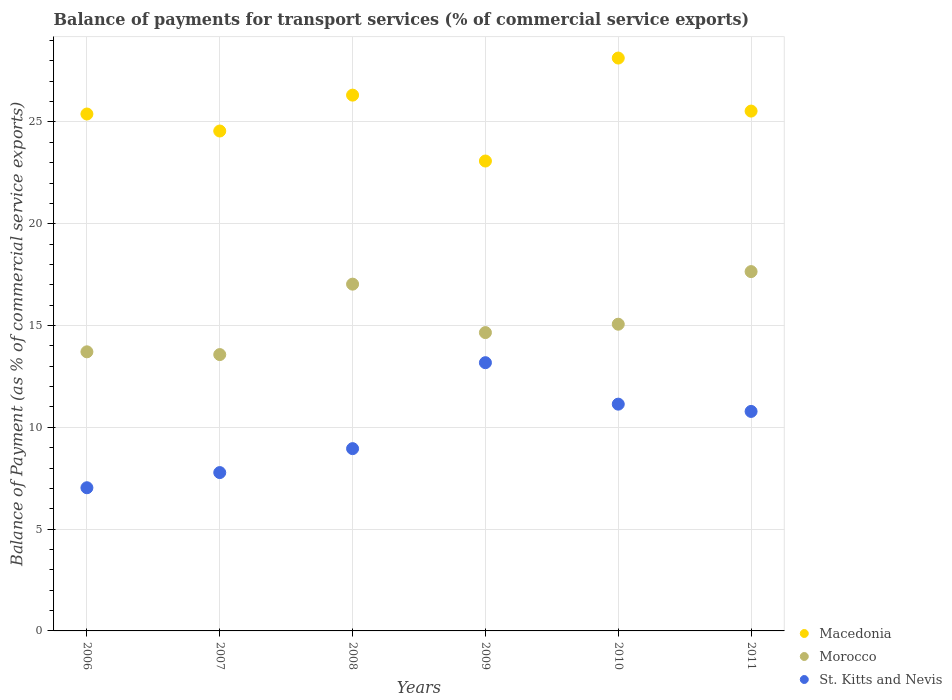How many different coloured dotlines are there?
Your answer should be very brief. 3. What is the balance of payments for transport services in Morocco in 2008?
Provide a short and direct response. 17.03. Across all years, what is the maximum balance of payments for transport services in Macedonia?
Your answer should be very brief. 28.14. Across all years, what is the minimum balance of payments for transport services in St. Kitts and Nevis?
Your response must be concise. 7.03. What is the total balance of payments for transport services in St. Kitts and Nevis in the graph?
Offer a terse response. 58.86. What is the difference between the balance of payments for transport services in Macedonia in 2006 and that in 2010?
Make the answer very short. -2.75. What is the difference between the balance of payments for transport services in St. Kitts and Nevis in 2006 and the balance of payments for transport services in Morocco in 2010?
Your answer should be very brief. -8.03. What is the average balance of payments for transport services in St. Kitts and Nevis per year?
Your answer should be compact. 9.81. In the year 2008, what is the difference between the balance of payments for transport services in Morocco and balance of payments for transport services in Macedonia?
Your response must be concise. -9.29. In how many years, is the balance of payments for transport services in Morocco greater than 22 %?
Offer a very short reply. 0. What is the ratio of the balance of payments for transport services in Morocco in 2009 to that in 2011?
Offer a terse response. 0.83. What is the difference between the highest and the second highest balance of payments for transport services in Morocco?
Your answer should be compact. 0.62. What is the difference between the highest and the lowest balance of payments for transport services in Macedonia?
Make the answer very short. 5.06. In how many years, is the balance of payments for transport services in Macedonia greater than the average balance of payments for transport services in Macedonia taken over all years?
Your answer should be compact. 3. Is the sum of the balance of payments for transport services in Macedonia in 2008 and 2010 greater than the maximum balance of payments for transport services in Morocco across all years?
Offer a terse response. Yes. Is the balance of payments for transport services in St. Kitts and Nevis strictly greater than the balance of payments for transport services in Macedonia over the years?
Your response must be concise. No. How many dotlines are there?
Provide a short and direct response. 3. How many years are there in the graph?
Provide a succinct answer. 6. Does the graph contain any zero values?
Your answer should be compact. No. How many legend labels are there?
Keep it short and to the point. 3. What is the title of the graph?
Provide a short and direct response. Balance of payments for transport services (% of commercial service exports). What is the label or title of the X-axis?
Provide a succinct answer. Years. What is the label or title of the Y-axis?
Your answer should be very brief. Balance of Payment (as % of commercial service exports). What is the Balance of Payment (as % of commercial service exports) in Macedonia in 2006?
Give a very brief answer. 25.39. What is the Balance of Payment (as % of commercial service exports) of Morocco in 2006?
Your answer should be very brief. 13.71. What is the Balance of Payment (as % of commercial service exports) of St. Kitts and Nevis in 2006?
Your answer should be very brief. 7.03. What is the Balance of Payment (as % of commercial service exports) of Macedonia in 2007?
Make the answer very short. 24.56. What is the Balance of Payment (as % of commercial service exports) of Morocco in 2007?
Ensure brevity in your answer.  13.57. What is the Balance of Payment (as % of commercial service exports) of St. Kitts and Nevis in 2007?
Provide a succinct answer. 7.78. What is the Balance of Payment (as % of commercial service exports) in Macedonia in 2008?
Keep it short and to the point. 26.32. What is the Balance of Payment (as % of commercial service exports) in Morocco in 2008?
Your answer should be very brief. 17.03. What is the Balance of Payment (as % of commercial service exports) in St. Kitts and Nevis in 2008?
Your answer should be compact. 8.95. What is the Balance of Payment (as % of commercial service exports) of Macedonia in 2009?
Your answer should be very brief. 23.08. What is the Balance of Payment (as % of commercial service exports) of Morocco in 2009?
Offer a terse response. 14.66. What is the Balance of Payment (as % of commercial service exports) of St. Kitts and Nevis in 2009?
Your answer should be compact. 13.18. What is the Balance of Payment (as % of commercial service exports) in Macedonia in 2010?
Your answer should be compact. 28.14. What is the Balance of Payment (as % of commercial service exports) in Morocco in 2010?
Your answer should be compact. 15.07. What is the Balance of Payment (as % of commercial service exports) in St. Kitts and Nevis in 2010?
Ensure brevity in your answer.  11.14. What is the Balance of Payment (as % of commercial service exports) in Macedonia in 2011?
Provide a short and direct response. 25.54. What is the Balance of Payment (as % of commercial service exports) in Morocco in 2011?
Ensure brevity in your answer.  17.65. What is the Balance of Payment (as % of commercial service exports) of St. Kitts and Nevis in 2011?
Make the answer very short. 10.78. Across all years, what is the maximum Balance of Payment (as % of commercial service exports) in Macedonia?
Offer a very short reply. 28.14. Across all years, what is the maximum Balance of Payment (as % of commercial service exports) of Morocco?
Your answer should be compact. 17.65. Across all years, what is the maximum Balance of Payment (as % of commercial service exports) of St. Kitts and Nevis?
Your response must be concise. 13.18. Across all years, what is the minimum Balance of Payment (as % of commercial service exports) of Macedonia?
Offer a terse response. 23.08. Across all years, what is the minimum Balance of Payment (as % of commercial service exports) in Morocco?
Make the answer very short. 13.57. Across all years, what is the minimum Balance of Payment (as % of commercial service exports) of St. Kitts and Nevis?
Your answer should be very brief. 7.03. What is the total Balance of Payment (as % of commercial service exports) of Macedonia in the graph?
Your answer should be very brief. 153.03. What is the total Balance of Payment (as % of commercial service exports) of Morocco in the graph?
Offer a very short reply. 91.69. What is the total Balance of Payment (as % of commercial service exports) in St. Kitts and Nevis in the graph?
Your answer should be compact. 58.86. What is the difference between the Balance of Payment (as % of commercial service exports) in Macedonia in 2006 and that in 2007?
Offer a terse response. 0.84. What is the difference between the Balance of Payment (as % of commercial service exports) in Morocco in 2006 and that in 2007?
Offer a terse response. 0.14. What is the difference between the Balance of Payment (as % of commercial service exports) of St. Kitts and Nevis in 2006 and that in 2007?
Your answer should be compact. -0.74. What is the difference between the Balance of Payment (as % of commercial service exports) of Macedonia in 2006 and that in 2008?
Provide a short and direct response. -0.93. What is the difference between the Balance of Payment (as % of commercial service exports) in Morocco in 2006 and that in 2008?
Provide a succinct answer. -3.32. What is the difference between the Balance of Payment (as % of commercial service exports) of St. Kitts and Nevis in 2006 and that in 2008?
Offer a very short reply. -1.92. What is the difference between the Balance of Payment (as % of commercial service exports) of Macedonia in 2006 and that in 2009?
Offer a terse response. 2.31. What is the difference between the Balance of Payment (as % of commercial service exports) in Morocco in 2006 and that in 2009?
Offer a very short reply. -0.94. What is the difference between the Balance of Payment (as % of commercial service exports) of St. Kitts and Nevis in 2006 and that in 2009?
Give a very brief answer. -6.14. What is the difference between the Balance of Payment (as % of commercial service exports) in Macedonia in 2006 and that in 2010?
Your response must be concise. -2.75. What is the difference between the Balance of Payment (as % of commercial service exports) of Morocco in 2006 and that in 2010?
Your answer should be very brief. -1.36. What is the difference between the Balance of Payment (as % of commercial service exports) in St. Kitts and Nevis in 2006 and that in 2010?
Your answer should be compact. -4.11. What is the difference between the Balance of Payment (as % of commercial service exports) in Macedonia in 2006 and that in 2011?
Your answer should be compact. -0.14. What is the difference between the Balance of Payment (as % of commercial service exports) in Morocco in 2006 and that in 2011?
Make the answer very short. -3.94. What is the difference between the Balance of Payment (as % of commercial service exports) in St. Kitts and Nevis in 2006 and that in 2011?
Provide a short and direct response. -3.75. What is the difference between the Balance of Payment (as % of commercial service exports) in Macedonia in 2007 and that in 2008?
Your answer should be compact. -1.76. What is the difference between the Balance of Payment (as % of commercial service exports) in Morocco in 2007 and that in 2008?
Ensure brevity in your answer.  -3.46. What is the difference between the Balance of Payment (as % of commercial service exports) of St. Kitts and Nevis in 2007 and that in 2008?
Keep it short and to the point. -1.18. What is the difference between the Balance of Payment (as % of commercial service exports) in Macedonia in 2007 and that in 2009?
Give a very brief answer. 1.47. What is the difference between the Balance of Payment (as % of commercial service exports) in Morocco in 2007 and that in 2009?
Offer a very short reply. -1.08. What is the difference between the Balance of Payment (as % of commercial service exports) in St. Kitts and Nevis in 2007 and that in 2009?
Give a very brief answer. -5.4. What is the difference between the Balance of Payment (as % of commercial service exports) of Macedonia in 2007 and that in 2010?
Provide a succinct answer. -3.58. What is the difference between the Balance of Payment (as % of commercial service exports) of Morocco in 2007 and that in 2010?
Offer a terse response. -1.49. What is the difference between the Balance of Payment (as % of commercial service exports) in St. Kitts and Nevis in 2007 and that in 2010?
Give a very brief answer. -3.36. What is the difference between the Balance of Payment (as % of commercial service exports) of Macedonia in 2007 and that in 2011?
Ensure brevity in your answer.  -0.98. What is the difference between the Balance of Payment (as % of commercial service exports) of Morocco in 2007 and that in 2011?
Give a very brief answer. -4.08. What is the difference between the Balance of Payment (as % of commercial service exports) of St. Kitts and Nevis in 2007 and that in 2011?
Your answer should be compact. -3. What is the difference between the Balance of Payment (as % of commercial service exports) in Macedonia in 2008 and that in 2009?
Keep it short and to the point. 3.24. What is the difference between the Balance of Payment (as % of commercial service exports) in Morocco in 2008 and that in 2009?
Ensure brevity in your answer.  2.38. What is the difference between the Balance of Payment (as % of commercial service exports) of St. Kitts and Nevis in 2008 and that in 2009?
Make the answer very short. -4.22. What is the difference between the Balance of Payment (as % of commercial service exports) of Macedonia in 2008 and that in 2010?
Your answer should be compact. -1.82. What is the difference between the Balance of Payment (as % of commercial service exports) in Morocco in 2008 and that in 2010?
Provide a succinct answer. 1.97. What is the difference between the Balance of Payment (as % of commercial service exports) in St. Kitts and Nevis in 2008 and that in 2010?
Your answer should be very brief. -2.19. What is the difference between the Balance of Payment (as % of commercial service exports) in Macedonia in 2008 and that in 2011?
Make the answer very short. 0.78. What is the difference between the Balance of Payment (as % of commercial service exports) in Morocco in 2008 and that in 2011?
Make the answer very short. -0.62. What is the difference between the Balance of Payment (as % of commercial service exports) of St. Kitts and Nevis in 2008 and that in 2011?
Make the answer very short. -1.83. What is the difference between the Balance of Payment (as % of commercial service exports) of Macedonia in 2009 and that in 2010?
Make the answer very short. -5.06. What is the difference between the Balance of Payment (as % of commercial service exports) of Morocco in 2009 and that in 2010?
Give a very brief answer. -0.41. What is the difference between the Balance of Payment (as % of commercial service exports) of St. Kitts and Nevis in 2009 and that in 2010?
Your answer should be very brief. 2.04. What is the difference between the Balance of Payment (as % of commercial service exports) in Macedonia in 2009 and that in 2011?
Provide a short and direct response. -2.45. What is the difference between the Balance of Payment (as % of commercial service exports) in Morocco in 2009 and that in 2011?
Keep it short and to the point. -3. What is the difference between the Balance of Payment (as % of commercial service exports) of St. Kitts and Nevis in 2009 and that in 2011?
Make the answer very short. 2.39. What is the difference between the Balance of Payment (as % of commercial service exports) in Macedonia in 2010 and that in 2011?
Ensure brevity in your answer.  2.6. What is the difference between the Balance of Payment (as % of commercial service exports) in Morocco in 2010 and that in 2011?
Your response must be concise. -2.58. What is the difference between the Balance of Payment (as % of commercial service exports) of St. Kitts and Nevis in 2010 and that in 2011?
Provide a succinct answer. 0.36. What is the difference between the Balance of Payment (as % of commercial service exports) in Macedonia in 2006 and the Balance of Payment (as % of commercial service exports) in Morocco in 2007?
Provide a succinct answer. 11.82. What is the difference between the Balance of Payment (as % of commercial service exports) in Macedonia in 2006 and the Balance of Payment (as % of commercial service exports) in St. Kitts and Nevis in 2007?
Your answer should be compact. 17.61. What is the difference between the Balance of Payment (as % of commercial service exports) in Morocco in 2006 and the Balance of Payment (as % of commercial service exports) in St. Kitts and Nevis in 2007?
Give a very brief answer. 5.93. What is the difference between the Balance of Payment (as % of commercial service exports) in Macedonia in 2006 and the Balance of Payment (as % of commercial service exports) in Morocco in 2008?
Provide a short and direct response. 8.36. What is the difference between the Balance of Payment (as % of commercial service exports) in Macedonia in 2006 and the Balance of Payment (as % of commercial service exports) in St. Kitts and Nevis in 2008?
Keep it short and to the point. 16.44. What is the difference between the Balance of Payment (as % of commercial service exports) of Morocco in 2006 and the Balance of Payment (as % of commercial service exports) of St. Kitts and Nevis in 2008?
Your answer should be very brief. 4.76. What is the difference between the Balance of Payment (as % of commercial service exports) of Macedonia in 2006 and the Balance of Payment (as % of commercial service exports) of Morocco in 2009?
Provide a short and direct response. 10.74. What is the difference between the Balance of Payment (as % of commercial service exports) of Macedonia in 2006 and the Balance of Payment (as % of commercial service exports) of St. Kitts and Nevis in 2009?
Provide a succinct answer. 12.22. What is the difference between the Balance of Payment (as % of commercial service exports) of Morocco in 2006 and the Balance of Payment (as % of commercial service exports) of St. Kitts and Nevis in 2009?
Provide a succinct answer. 0.53. What is the difference between the Balance of Payment (as % of commercial service exports) in Macedonia in 2006 and the Balance of Payment (as % of commercial service exports) in Morocco in 2010?
Provide a short and direct response. 10.33. What is the difference between the Balance of Payment (as % of commercial service exports) in Macedonia in 2006 and the Balance of Payment (as % of commercial service exports) in St. Kitts and Nevis in 2010?
Provide a succinct answer. 14.25. What is the difference between the Balance of Payment (as % of commercial service exports) of Morocco in 2006 and the Balance of Payment (as % of commercial service exports) of St. Kitts and Nevis in 2010?
Provide a succinct answer. 2.57. What is the difference between the Balance of Payment (as % of commercial service exports) in Macedonia in 2006 and the Balance of Payment (as % of commercial service exports) in Morocco in 2011?
Provide a short and direct response. 7.74. What is the difference between the Balance of Payment (as % of commercial service exports) of Macedonia in 2006 and the Balance of Payment (as % of commercial service exports) of St. Kitts and Nevis in 2011?
Make the answer very short. 14.61. What is the difference between the Balance of Payment (as % of commercial service exports) in Morocco in 2006 and the Balance of Payment (as % of commercial service exports) in St. Kitts and Nevis in 2011?
Offer a very short reply. 2.93. What is the difference between the Balance of Payment (as % of commercial service exports) in Macedonia in 2007 and the Balance of Payment (as % of commercial service exports) in Morocco in 2008?
Your response must be concise. 7.52. What is the difference between the Balance of Payment (as % of commercial service exports) in Macedonia in 2007 and the Balance of Payment (as % of commercial service exports) in St. Kitts and Nevis in 2008?
Make the answer very short. 15.6. What is the difference between the Balance of Payment (as % of commercial service exports) of Morocco in 2007 and the Balance of Payment (as % of commercial service exports) of St. Kitts and Nevis in 2008?
Ensure brevity in your answer.  4.62. What is the difference between the Balance of Payment (as % of commercial service exports) of Macedonia in 2007 and the Balance of Payment (as % of commercial service exports) of Morocco in 2009?
Keep it short and to the point. 9.9. What is the difference between the Balance of Payment (as % of commercial service exports) of Macedonia in 2007 and the Balance of Payment (as % of commercial service exports) of St. Kitts and Nevis in 2009?
Ensure brevity in your answer.  11.38. What is the difference between the Balance of Payment (as % of commercial service exports) in Morocco in 2007 and the Balance of Payment (as % of commercial service exports) in St. Kitts and Nevis in 2009?
Provide a succinct answer. 0.4. What is the difference between the Balance of Payment (as % of commercial service exports) in Macedonia in 2007 and the Balance of Payment (as % of commercial service exports) in Morocco in 2010?
Give a very brief answer. 9.49. What is the difference between the Balance of Payment (as % of commercial service exports) of Macedonia in 2007 and the Balance of Payment (as % of commercial service exports) of St. Kitts and Nevis in 2010?
Offer a terse response. 13.42. What is the difference between the Balance of Payment (as % of commercial service exports) in Morocco in 2007 and the Balance of Payment (as % of commercial service exports) in St. Kitts and Nevis in 2010?
Your response must be concise. 2.44. What is the difference between the Balance of Payment (as % of commercial service exports) in Macedonia in 2007 and the Balance of Payment (as % of commercial service exports) in Morocco in 2011?
Give a very brief answer. 6.91. What is the difference between the Balance of Payment (as % of commercial service exports) in Macedonia in 2007 and the Balance of Payment (as % of commercial service exports) in St. Kitts and Nevis in 2011?
Offer a terse response. 13.77. What is the difference between the Balance of Payment (as % of commercial service exports) in Morocco in 2007 and the Balance of Payment (as % of commercial service exports) in St. Kitts and Nevis in 2011?
Provide a succinct answer. 2.79. What is the difference between the Balance of Payment (as % of commercial service exports) of Macedonia in 2008 and the Balance of Payment (as % of commercial service exports) of Morocco in 2009?
Ensure brevity in your answer.  11.66. What is the difference between the Balance of Payment (as % of commercial service exports) of Macedonia in 2008 and the Balance of Payment (as % of commercial service exports) of St. Kitts and Nevis in 2009?
Offer a terse response. 13.14. What is the difference between the Balance of Payment (as % of commercial service exports) in Morocco in 2008 and the Balance of Payment (as % of commercial service exports) in St. Kitts and Nevis in 2009?
Offer a very short reply. 3.86. What is the difference between the Balance of Payment (as % of commercial service exports) in Macedonia in 2008 and the Balance of Payment (as % of commercial service exports) in Morocco in 2010?
Give a very brief answer. 11.25. What is the difference between the Balance of Payment (as % of commercial service exports) in Macedonia in 2008 and the Balance of Payment (as % of commercial service exports) in St. Kitts and Nevis in 2010?
Your answer should be compact. 15.18. What is the difference between the Balance of Payment (as % of commercial service exports) of Morocco in 2008 and the Balance of Payment (as % of commercial service exports) of St. Kitts and Nevis in 2010?
Your answer should be compact. 5.89. What is the difference between the Balance of Payment (as % of commercial service exports) of Macedonia in 2008 and the Balance of Payment (as % of commercial service exports) of Morocco in 2011?
Your answer should be very brief. 8.67. What is the difference between the Balance of Payment (as % of commercial service exports) in Macedonia in 2008 and the Balance of Payment (as % of commercial service exports) in St. Kitts and Nevis in 2011?
Provide a short and direct response. 15.54. What is the difference between the Balance of Payment (as % of commercial service exports) in Morocco in 2008 and the Balance of Payment (as % of commercial service exports) in St. Kitts and Nevis in 2011?
Your response must be concise. 6.25. What is the difference between the Balance of Payment (as % of commercial service exports) of Macedonia in 2009 and the Balance of Payment (as % of commercial service exports) of Morocco in 2010?
Give a very brief answer. 8.02. What is the difference between the Balance of Payment (as % of commercial service exports) of Macedonia in 2009 and the Balance of Payment (as % of commercial service exports) of St. Kitts and Nevis in 2010?
Your response must be concise. 11.94. What is the difference between the Balance of Payment (as % of commercial service exports) of Morocco in 2009 and the Balance of Payment (as % of commercial service exports) of St. Kitts and Nevis in 2010?
Offer a terse response. 3.52. What is the difference between the Balance of Payment (as % of commercial service exports) of Macedonia in 2009 and the Balance of Payment (as % of commercial service exports) of Morocco in 2011?
Keep it short and to the point. 5.43. What is the difference between the Balance of Payment (as % of commercial service exports) of Macedonia in 2009 and the Balance of Payment (as % of commercial service exports) of St. Kitts and Nevis in 2011?
Offer a terse response. 12.3. What is the difference between the Balance of Payment (as % of commercial service exports) in Morocco in 2009 and the Balance of Payment (as % of commercial service exports) in St. Kitts and Nevis in 2011?
Keep it short and to the point. 3.87. What is the difference between the Balance of Payment (as % of commercial service exports) of Macedonia in 2010 and the Balance of Payment (as % of commercial service exports) of Morocco in 2011?
Keep it short and to the point. 10.49. What is the difference between the Balance of Payment (as % of commercial service exports) in Macedonia in 2010 and the Balance of Payment (as % of commercial service exports) in St. Kitts and Nevis in 2011?
Provide a succinct answer. 17.36. What is the difference between the Balance of Payment (as % of commercial service exports) of Morocco in 2010 and the Balance of Payment (as % of commercial service exports) of St. Kitts and Nevis in 2011?
Your response must be concise. 4.28. What is the average Balance of Payment (as % of commercial service exports) in Macedonia per year?
Offer a very short reply. 25.5. What is the average Balance of Payment (as % of commercial service exports) in Morocco per year?
Your answer should be very brief. 15.28. What is the average Balance of Payment (as % of commercial service exports) in St. Kitts and Nevis per year?
Make the answer very short. 9.81. In the year 2006, what is the difference between the Balance of Payment (as % of commercial service exports) of Macedonia and Balance of Payment (as % of commercial service exports) of Morocco?
Keep it short and to the point. 11.68. In the year 2006, what is the difference between the Balance of Payment (as % of commercial service exports) of Macedonia and Balance of Payment (as % of commercial service exports) of St. Kitts and Nevis?
Provide a short and direct response. 18.36. In the year 2006, what is the difference between the Balance of Payment (as % of commercial service exports) in Morocco and Balance of Payment (as % of commercial service exports) in St. Kitts and Nevis?
Your response must be concise. 6.68. In the year 2007, what is the difference between the Balance of Payment (as % of commercial service exports) of Macedonia and Balance of Payment (as % of commercial service exports) of Morocco?
Offer a very short reply. 10.98. In the year 2007, what is the difference between the Balance of Payment (as % of commercial service exports) of Macedonia and Balance of Payment (as % of commercial service exports) of St. Kitts and Nevis?
Give a very brief answer. 16.78. In the year 2007, what is the difference between the Balance of Payment (as % of commercial service exports) of Morocco and Balance of Payment (as % of commercial service exports) of St. Kitts and Nevis?
Ensure brevity in your answer.  5.8. In the year 2008, what is the difference between the Balance of Payment (as % of commercial service exports) in Macedonia and Balance of Payment (as % of commercial service exports) in Morocco?
Provide a succinct answer. 9.29. In the year 2008, what is the difference between the Balance of Payment (as % of commercial service exports) in Macedonia and Balance of Payment (as % of commercial service exports) in St. Kitts and Nevis?
Your answer should be very brief. 17.37. In the year 2008, what is the difference between the Balance of Payment (as % of commercial service exports) in Morocco and Balance of Payment (as % of commercial service exports) in St. Kitts and Nevis?
Offer a very short reply. 8.08. In the year 2009, what is the difference between the Balance of Payment (as % of commercial service exports) of Macedonia and Balance of Payment (as % of commercial service exports) of Morocco?
Your response must be concise. 8.43. In the year 2009, what is the difference between the Balance of Payment (as % of commercial service exports) in Macedonia and Balance of Payment (as % of commercial service exports) in St. Kitts and Nevis?
Ensure brevity in your answer.  9.91. In the year 2009, what is the difference between the Balance of Payment (as % of commercial service exports) in Morocco and Balance of Payment (as % of commercial service exports) in St. Kitts and Nevis?
Keep it short and to the point. 1.48. In the year 2010, what is the difference between the Balance of Payment (as % of commercial service exports) of Macedonia and Balance of Payment (as % of commercial service exports) of Morocco?
Make the answer very short. 13.07. In the year 2010, what is the difference between the Balance of Payment (as % of commercial service exports) in Macedonia and Balance of Payment (as % of commercial service exports) in St. Kitts and Nevis?
Keep it short and to the point. 17. In the year 2010, what is the difference between the Balance of Payment (as % of commercial service exports) in Morocco and Balance of Payment (as % of commercial service exports) in St. Kitts and Nevis?
Offer a very short reply. 3.93. In the year 2011, what is the difference between the Balance of Payment (as % of commercial service exports) of Macedonia and Balance of Payment (as % of commercial service exports) of Morocco?
Offer a terse response. 7.89. In the year 2011, what is the difference between the Balance of Payment (as % of commercial service exports) in Macedonia and Balance of Payment (as % of commercial service exports) in St. Kitts and Nevis?
Your answer should be very brief. 14.75. In the year 2011, what is the difference between the Balance of Payment (as % of commercial service exports) in Morocco and Balance of Payment (as % of commercial service exports) in St. Kitts and Nevis?
Offer a very short reply. 6.87. What is the ratio of the Balance of Payment (as % of commercial service exports) of Macedonia in 2006 to that in 2007?
Provide a short and direct response. 1.03. What is the ratio of the Balance of Payment (as % of commercial service exports) in Morocco in 2006 to that in 2007?
Give a very brief answer. 1.01. What is the ratio of the Balance of Payment (as % of commercial service exports) of St. Kitts and Nevis in 2006 to that in 2007?
Your response must be concise. 0.9. What is the ratio of the Balance of Payment (as % of commercial service exports) in Macedonia in 2006 to that in 2008?
Provide a succinct answer. 0.96. What is the ratio of the Balance of Payment (as % of commercial service exports) of Morocco in 2006 to that in 2008?
Keep it short and to the point. 0.8. What is the ratio of the Balance of Payment (as % of commercial service exports) of St. Kitts and Nevis in 2006 to that in 2008?
Ensure brevity in your answer.  0.79. What is the ratio of the Balance of Payment (as % of commercial service exports) in Macedonia in 2006 to that in 2009?
Provide a short and direct response. 1.1. What is the ratio of the Balance of Payment (as % of commercial service exports) of Morocco in 2006 to that in 2009?
Make the answer very short. 0.94. What is the ratio of the Balance of Payment (as % of commercial service exports) in St. Kitts and Nevis in 2006 to that in 2009?
Your answer should be compact. 0.53. What is the ratio of the Balance of Payment (as % of commercial service exports) of Macedonia in 2006 to that in 2010?
Give a very brief answer. 0.9. What is the ratio of the Balance of Payment (as % of commercial service exports) in Morocco in 2006 to that in 2010?
Provide a succinct answer. 0.91. What is the ratio of the Balance of Payment (as % of commercial service exports) in St. Kitts and Nevis in 2006 to that in 2010?
Make the answer very short. 0.63. What is the ratio of the Balance of Payment (as % of commercial service exports) of Macedonia in 2006 to that in 2011?
Your response must be concise. 0.99. What is the ratio of the Balance of Payment (as % of commercial service exports) of Morocco in 2006 to that in 2011?
Your response must be concise. 0.78. What is the ratio of the Balance of Payment (as % of commercial service exports) of St. Kitts and Nevis in 2006 to that in 2011?
Your response must be concise. 0.65. What is the ratio of the Balance of Payment (as % of commercial service exports) of Macedonia in 2007 to that in 2008?
Provide a short and direct response. 0.93. What is the ratio of the Balance of Payment (as % of commercial service exports) in Morocco in 2007 to that in 2008?
Offer a very short reply. 0.8. What is the ratio of the Balance of Payment (as % of commercial service exports) in St. Kitts and Nevis in 2007 to that in 2008?
Provide a succinct answer. 0.87. What is the ratio of the Balance of Payment (as % of commercial service exports) of Macedonia in 2007 to that in 2009?
Offer a very short reply. 1.06. What is the ratio of the Balance of Payment (as % of commercial service exports) of Morocco in 2007 to that in 2009?
Provide a short and direct response. 0.93. What is the ratio of the Balance of Payment (as % of commercial service exports) of St. Kitts and Nevis in 2007 to that in 2009?
Offer a terse response. 0.59. What is the ratio of the Balance of Payment (as % of commercial service exports) of Macedonia in 2007 to that in 2010?
Your answer should be compact. 0.87. What is the ratio of the Balance of Payment (as % of commercial service exports) of Morocco in 2007 to that in 2010?
Offer a very short reply. 0.9. What is the ratio of the Balance of Payment (as % of commercial service exports) of St. Kitts and Nevis in 2007 to that in 2010?
Your answer should be compact. 0.7. What is the ratio of the Balance of Payment (as % of commercial service exports) in Macedonia in 2007 to that in 2011?
Give a very brief answer. 0.96. What is the ratio of the Balance of Payment (as % of commercial service exports) of Morocco in 2007 to that in 2011?
Your response must be concise. 0.77. What is the ratio of the Balance of Payment (as % of commercial service exports) of St. Kitts and Nevis in 2007 to that in 2011?
Provide a succinct answer. 0.72. What is the ratio of the Balance of Payment (as % of commercial service exports) of Macedonia in 2008 to that in 2009?
Your response must be concise. 1.14. What is the ratio of the Balance of Payment (as % of commercial service exports) in Morocco in 2008 to that in 2009?
Ensure brevity in your answer.  1.16. What is the ratio of the Balance of Payment (as % of commercial service exports) of St. Kitts and Nevis in 2008 to that in 2009?
Your answer should be compact. 0.68. What is the ratio of the Balance of Payment (as % of commercial service exports) in Macedonia in 2008 to that in 2010?
Make the answer very short. 0.94. What is the ratio of the Balance of Payment (as % of commercial service exports) in Morocco in 2008 to that in 2010?
Provide a short and direct response. 1.13. What is the ratio of the Balance of Payment (as % of commercial service exports) in St. Kitts and Nevis in 2008 to that in 2010?
Keep it short and to the point. 0.8. What is the ratio of the Balance of Payment (as % of commercial service exports) of Macedonia in 2008 to that in 2011?
Provide a short and direct response. 1.03. What is the ratio of the Balance of Payment (as % of commercial service exports) in Morocco in 2008 to that in 2011?
Provide a succinct answer. 0.97. What is the ratio of the Balance of Payment (as % of commercial service exports) in St. Kitts and Nevis in 2008 to that in 2011?
Offer a very short reply. 0.83. What is the ratio of the Balance of Payment (as % of commercial service exports) of Macedonia in 2009 to that in 2010?
Offer a terse response. 0.82. What is the ratio of the Balance of Payment (as % of commercial service exports) of Morocco in 2009 to that in 2010?
Offer a terse response. 0.97. What is the ratio of the Balance of Payment (as % of commercial service exports) of St. Kitts and Nevis in 2009 to that in 2010?
Make the answer very short. 1.18. What is the ratio of the Balance of Payment (as % of commercial service exports) of Macedonia in 2009 to that in 2011?
Keep it short and to the point. 0.9. What is the ratio of the Balance of Payment (as % of commercial service exports) in Morocco in 2009 to that in 2011?
Your response must be concise. 0.83. What is the ratio of the Balance of Payment (as % of commercial service exports) in St. Kitts and Nevis in 2009 to that in 2011?
Provide a succinct answer. 1.22. What is the ratio of the Balance of Payment (as % of commercial service exports) in Macedonia in 2010 to that in 2011?
Offer a very short reply. 1.1. What is the ratio of the Balance of Payment (as % of commercial service exports) of Morocco in 2010 to that in 2011?
Keep it short and to the point. 0.85. What is the ratio of the Balance of Payment (as % of commercial service exports) of St. Kitts and Nevis in 2010 to that in 2011?
Offer a very short reply. 1.03. What is the difference between the highest and the second highest Balance of Payment (as % of commercial service exports) in Macedonia?
Offer a very short reply. 1.82. What is the difference between the highest and the second highest Balance of Payment (as % of commercial service exports) in Morocco?
Your response must be concise. 0.62. What is the difference between the highest and the second highest Balance of Payment (as % of commercial service exports) in St. Kitts and Nevis?
Give a very brief answer. 2.04. What is the difference between the highest and the lowest Balance of Payment (as % of commercial service exports) of Macedonia?
Your answer should be very brief. 5.06. What is the difference between the highest and the lowest Balance of Payment (as % of commercial service exports) in Morocco?
Your answer should be compact. 4.08. What is the difference between the highest and the lowest Balance of Payment (as % of commercial service exports) in St. Kitts and Nevis?
Your answer should be compact. 6.14. 